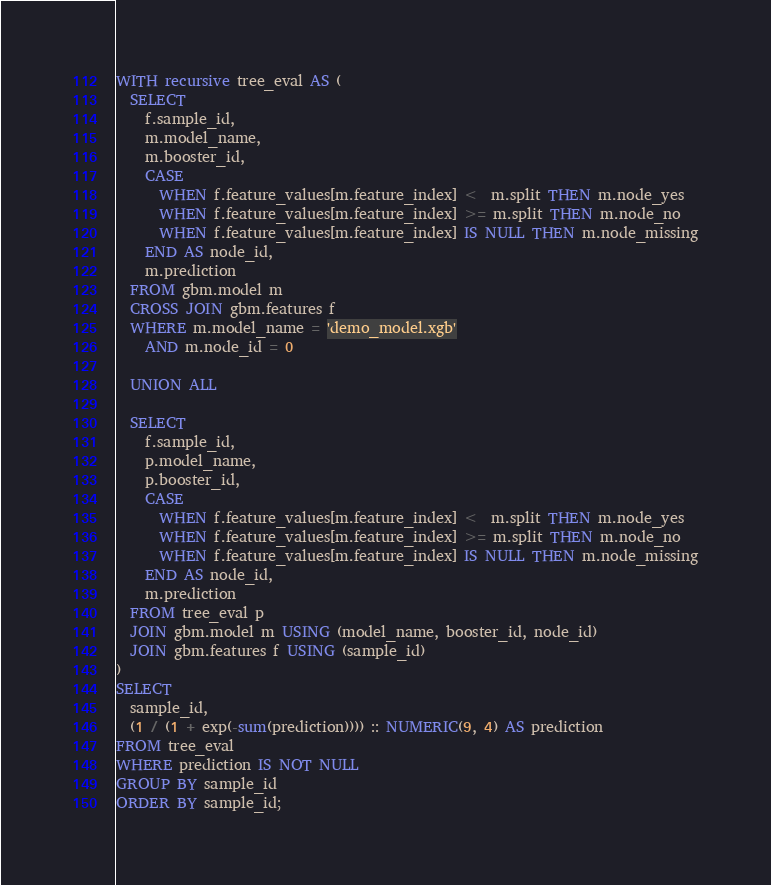Convert code to text. <code><loc_0><loc_0><loc_500><loc_500><_SQL_>WITH recursive tree_eval AS (
  SELECT
    f.sample_id,
    m.model_name,
    m.booster_id,
    CASE
      WHEN f.feature_values[m.feature_index] <  m.split THEN m.node_yes
      WHEN f.feature_values[m.feature_index] >= m.split THEN m.node_no
      WHEN f.feature_values[m.feature_index] IS NULL THEN m.node_missing
    END AS node_id,
    m.prediction
  FROM gbm.model m
  CROSS JOIN gbm.features f
  WHERE m.model_name = 'demo_model.xgb'
    AND m.node_id = 0

  UNION ALL

  SELECT
    f.sample_id,
    p.model_name,
    p.booster_id,
    CASE
      WHEN f.feature_values[m.feature_index] <  m.split THEN m.node_yes
      WHEN f.feature_values[m.feature_index] >= m.split THEN m.node_no
      WHEN f.feature_values[m.feature_index] IS NULL THEN m.node_missing
    END AS node_id,
    m.prediction
  FROM tree_eval p
  JOIN gbm.model m USING (model_name, booster_id, node_id)
  JOIN gbm.features f USING (sample_id)
)
SELECT
  sample_id,
  (1 / (1 + exp(-sum(prediction)))) :: NUMERIC(9, 4) AS prediction
FROM tree_eval
WHERE prediction IS NOT NULL
GROUP BY sample_id
ORDER BY sample_id;
</code> 